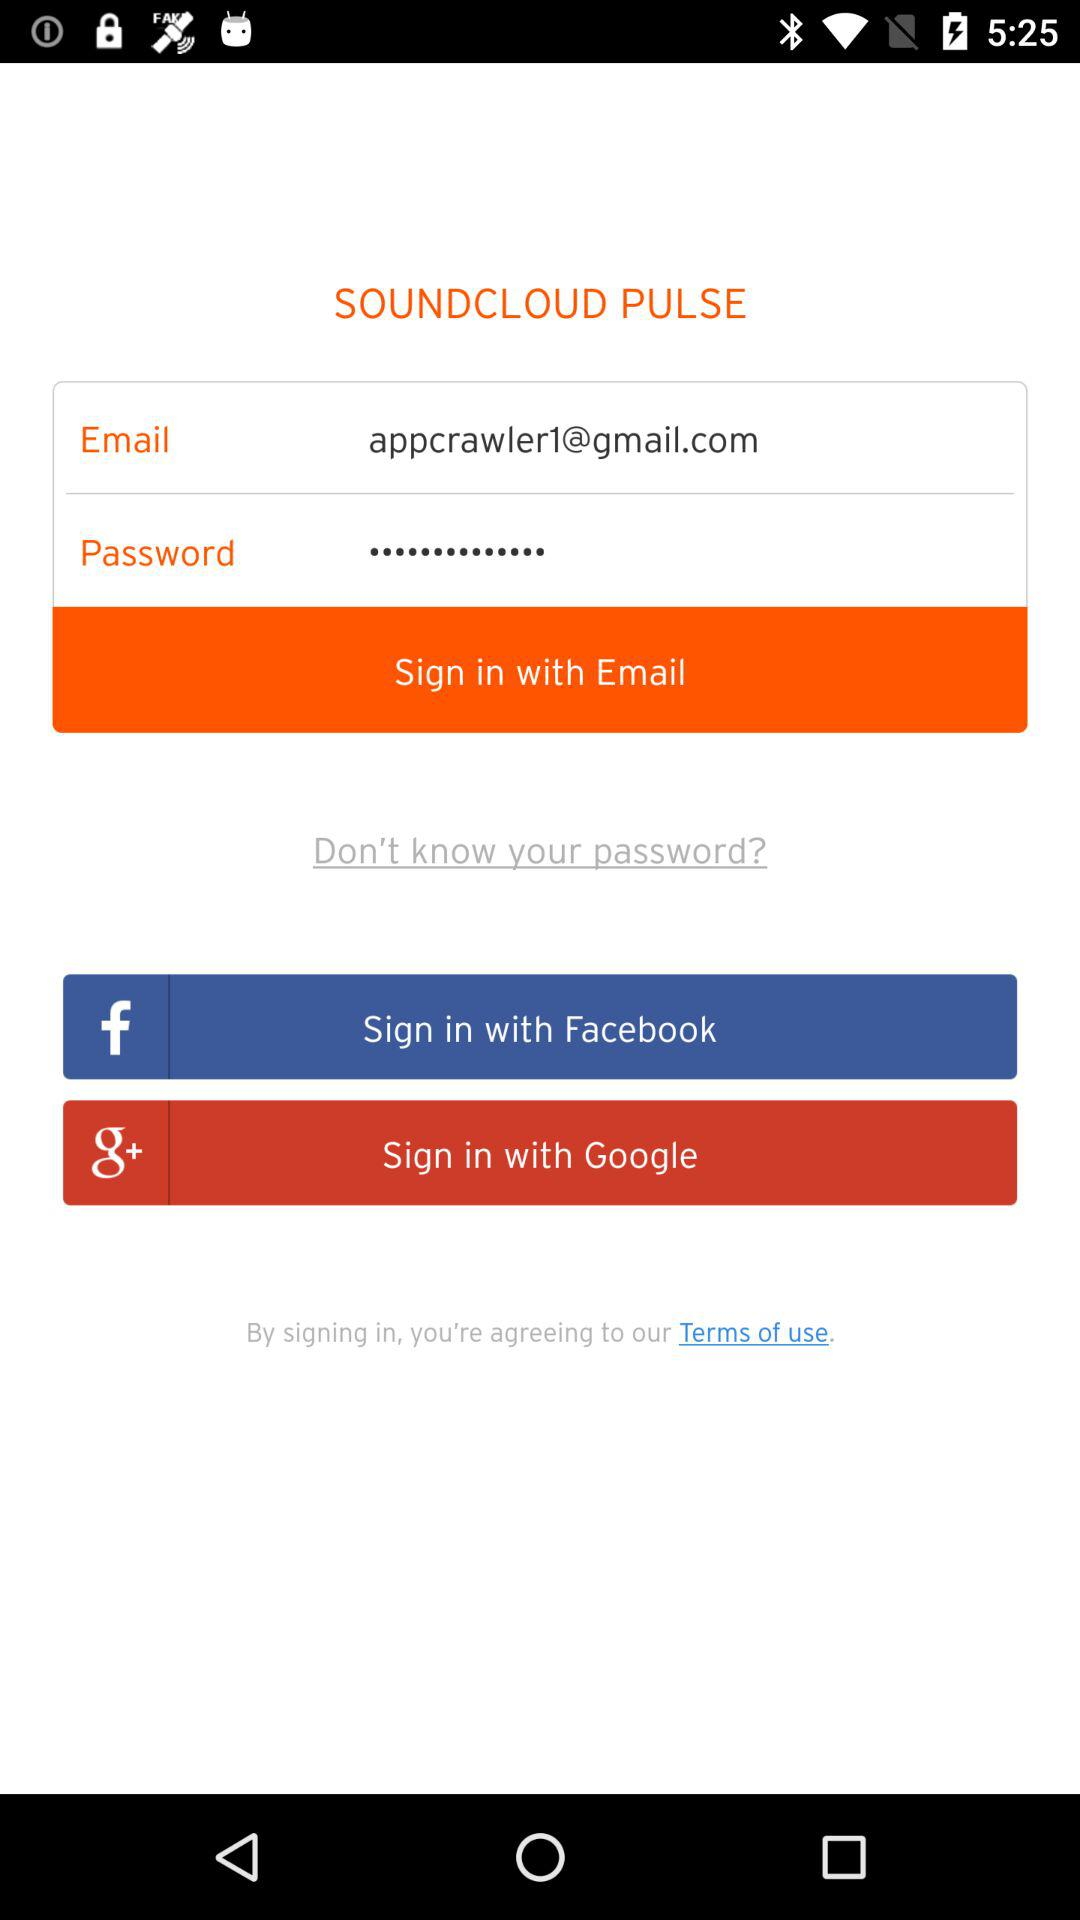What is the email addres? The email address is appcrawler1@gmail.com. 